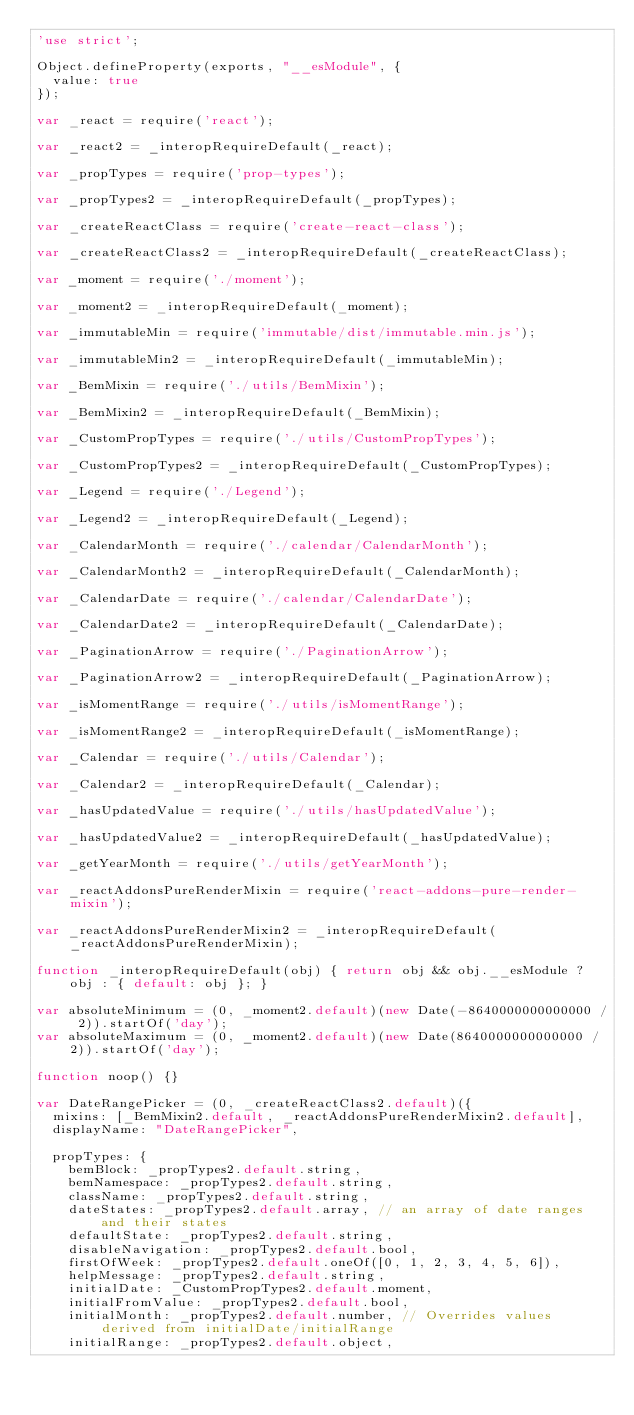Convert code to text. <code><loc_0><loc_0><loc_500><loc_500><_JavaScript_>'use strict';

Object.defineProperty(exports, "__esModule", {
  value: true
});

var _react = require('react');

var _react2 = _interopRequireDefault(_react);

var _propTypes = require('prop-types');

var _propTypes2 = _interopRequireDefault(_propTypes);

var _createReactClass = require('create-react-class');

var _createReactClass2 = _interopRequireDefault(_createReactClass);

var _moment = require('./moment');

var _moment2 = _interopRequireDefault(_moment);

var _immutableMin = require('immutable/dist/immutable.min.js');

var _immutableMin2 = _interopRequireDefault(_immutableMin);

var _BemMixin = require('./utils/BemMixin');

var _BemMixin2 = _interopRequireDefault(_BemMixin);

var _CustomPropTypes = require('./utils/CustomPropTypes');

var _CustomPropTypes2 = _interopRequireDefault(_CustomPropTypes);

var _Legend = require('./Legend');

var _Legend2 = _interopRequireDefault(_Legend);

var _CalendarMonth = require('./calendar/CalendarMonth');

var _CalendarMonth2 = _interopRequireDefault(_CalendarMonth);

var _CalendarDate = require('./calendar/CalendarDate');

var _CalendarDate2 = _interopRequireDefault(_CalendarDate);

var _PaginationArrow = require('./PaginationArrow');

var _PaginationArrow2 = _interopRequireDefault(_PaginationArrow);

var _isMomentRange = require('./utils/isMomentRange');

var _isMomentRange2 = _interopRequireDefault(_isMomentRange);

var _Calendar = require('./utils/Calendar');

var _Calendar2 = _interopRequireDefault(_Calendar);

var _hasUpdatedValue = require('./utils/hasUpdatedValue');

var _hasUpdatedValue2 = _interopRequireDefault(_hasUpdatedValue);

var _getYearMonth = require('./utils/getYearMonth');

var _reactAddonsPureRenderMixin = require('react-addons-pure-render-mixin');

var _reactAddonsPureRenderMixin2 = _interopRequireDefault(_reactAddonsPureRenderMixin);

function _interopRequireDefault(obj) { return obj && obj.__esModule ? obj : { default: obj }; }

var absoluteMinimum = (0, _moment2.default)(new Date(-8640000000000000 / 2)).startOf('day');
var absoluteMaximum = (0, _moment2.default)(new Date(8640000000000000 / 2)).startOf('day');

function noop() {}

var DateRangePicker = (0, _createReactClass2.default)({
  mixins: [_BemMixin2.default, _reactAddonsPureRenderMixin2.default],
  displayName: "DateRangePicker",

  propTypes: {
    bemBlock: _propTypes2.default.string,
    bemNamespace: _propTypes2.default.string,
    className: _propTypes2.default.string,
    dateStates: _propTypes2.default.array, // an array of date ranges and their states
    defaultState: _propTypes2.default.string,
    disableNavigation: _propTypes2.default.bool,
    firstOfWeek: _propTypes2.default.oneOf([0, 1, 2, 3, 4, 5, 6]),
    helpMessage: _propTypes2.default.string,
    initialDate: _CustomPropTypes2.default.moment,
    initialFromValue: _propTypes2.default.bool,
    initialMonth: _propTypes2.default.number, // Overrides values derived from initialDate/initialRange
    initialRange: _propTypes2.default.object,</code> 